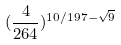Convert formula to latex. <formula><loc_0><loc_0><loc_500><loc_500>( \frac { 4 } { 2 6 4 } ) ^ { 1 0 / 1 9 7 - \sqrt { 9 } }</formula> 